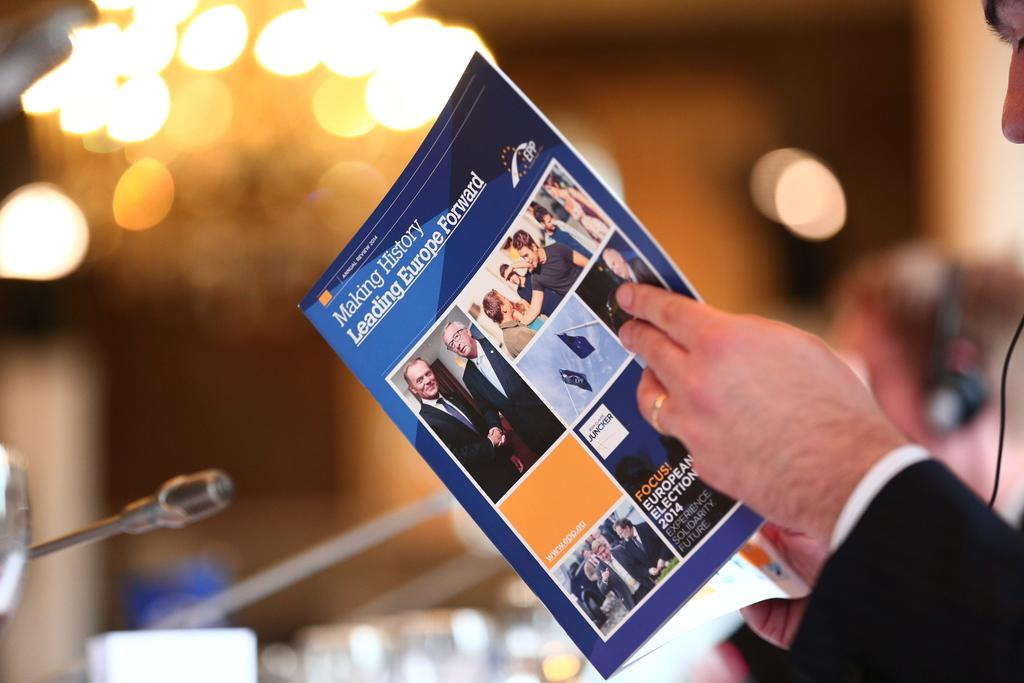What is the person in the foreground of the image holding? The person is holding a magazine in the image. Can you describe the person in the background of the image? There is a person in the background of the image, but no specific details are provided. What can be seen in the background of the image? Focus lights and a wall are present in the background of the image. What type of location might the image have been taken in? The image may have been taken in a hall, based on the presence of a wall and the background elements. What type of volcano can be seen erupting in the background of the image? There is no volcano present in the image; the background elements include focus lights and a wall. 